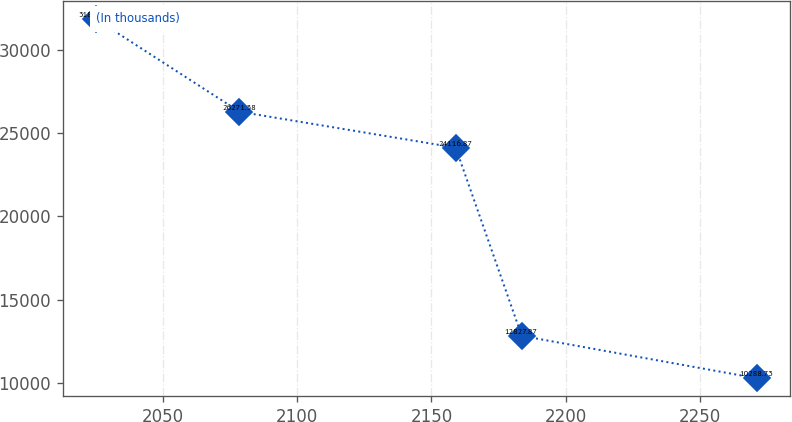Convert chart. <chart><loc_0><loc_0><loc_500><loc_500><line_chart><ecel><fcel>(In thousands)<nl><fcel>2025.04<fcel>31833.9<nl><fcel>2078.56<fcel>26271.4<nl><fcel>2159.03<fcel>24116.9<nl><fcel>2183.63<fcel>12827.9<nl><fcel>2271.02<fcel>10288.7<nl></chart> 